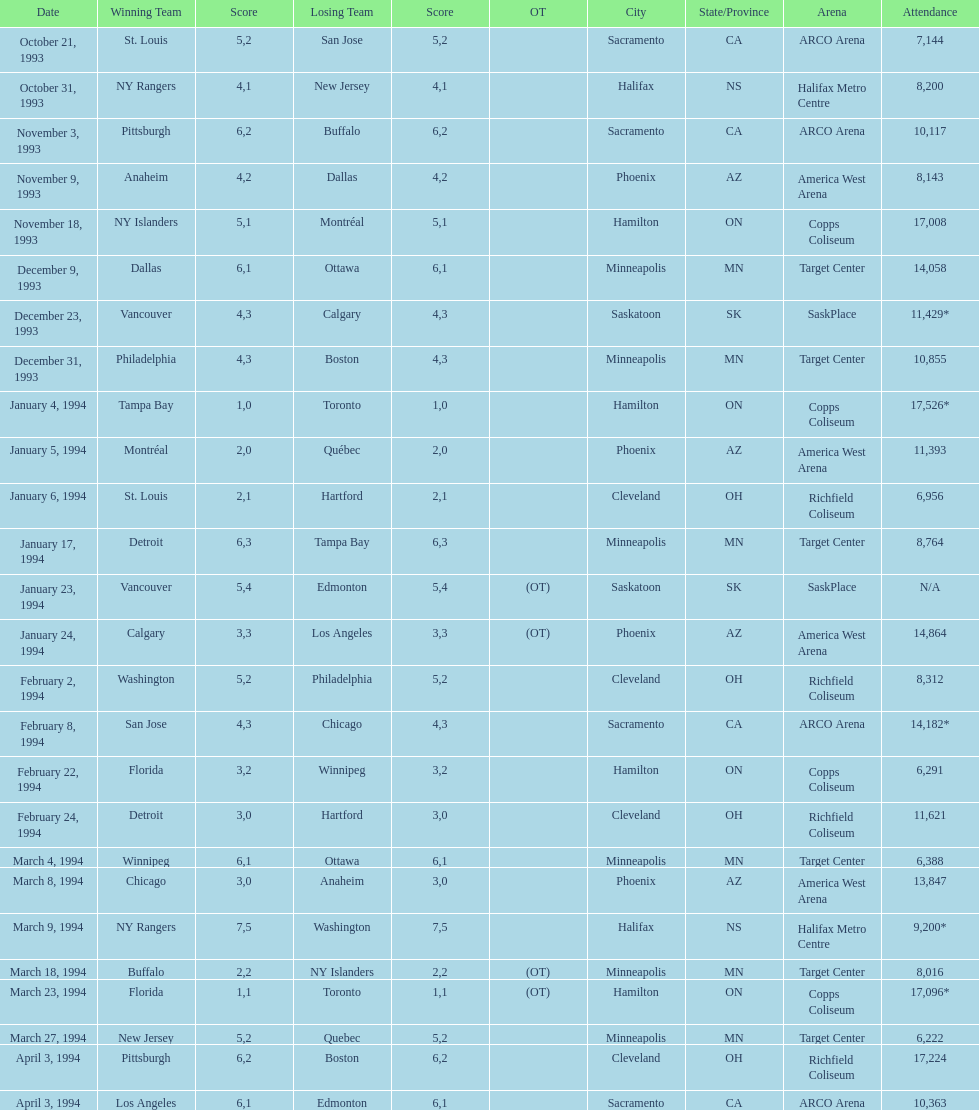How many more people attended the november 18, 1993 games than the november 9th game? 8865. 